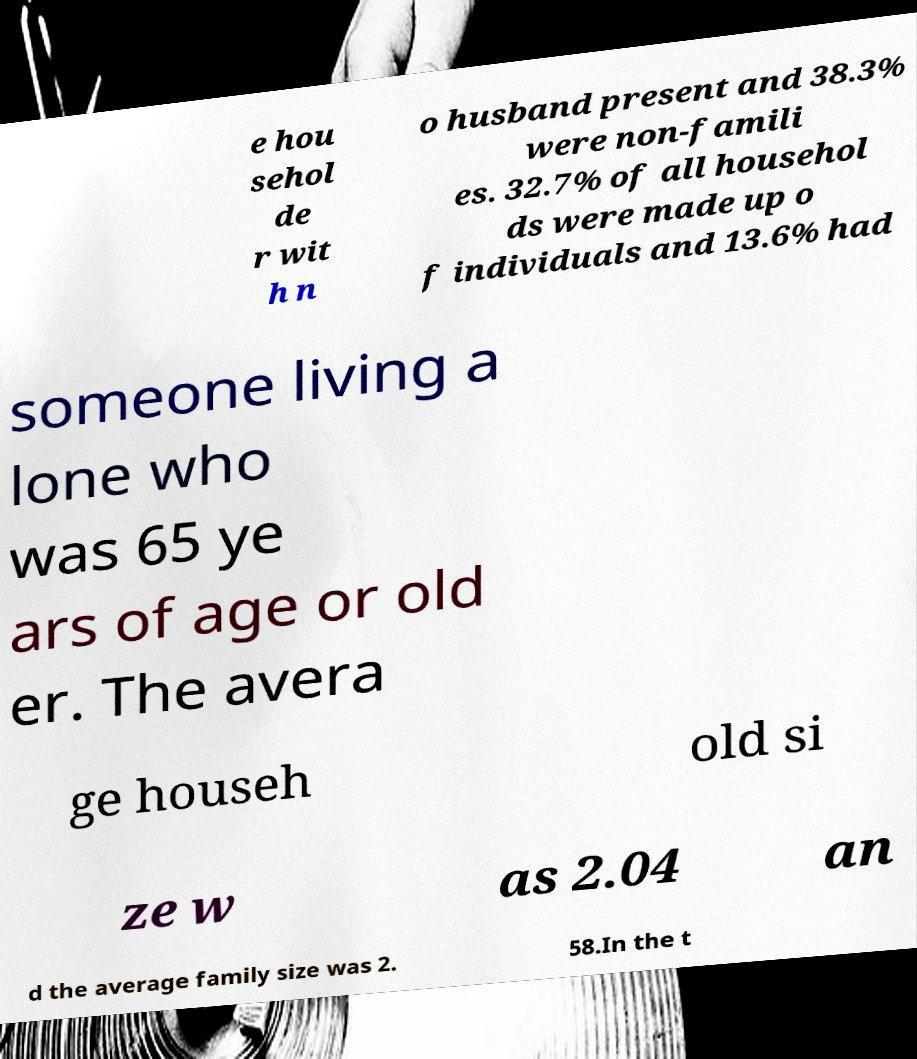Can you accurately transcribe the text from the provided image for me? e hou sehol de r wit h n o husband present and 38.3% were non-famili es. 32.7% of all househol ds were made up o f individuals and 13.6% had someone living a lone who was 65 ye ars of age or old er. The avera ge househ old si ze w as 2.04 an d the average family size was 2. 58.In the t 